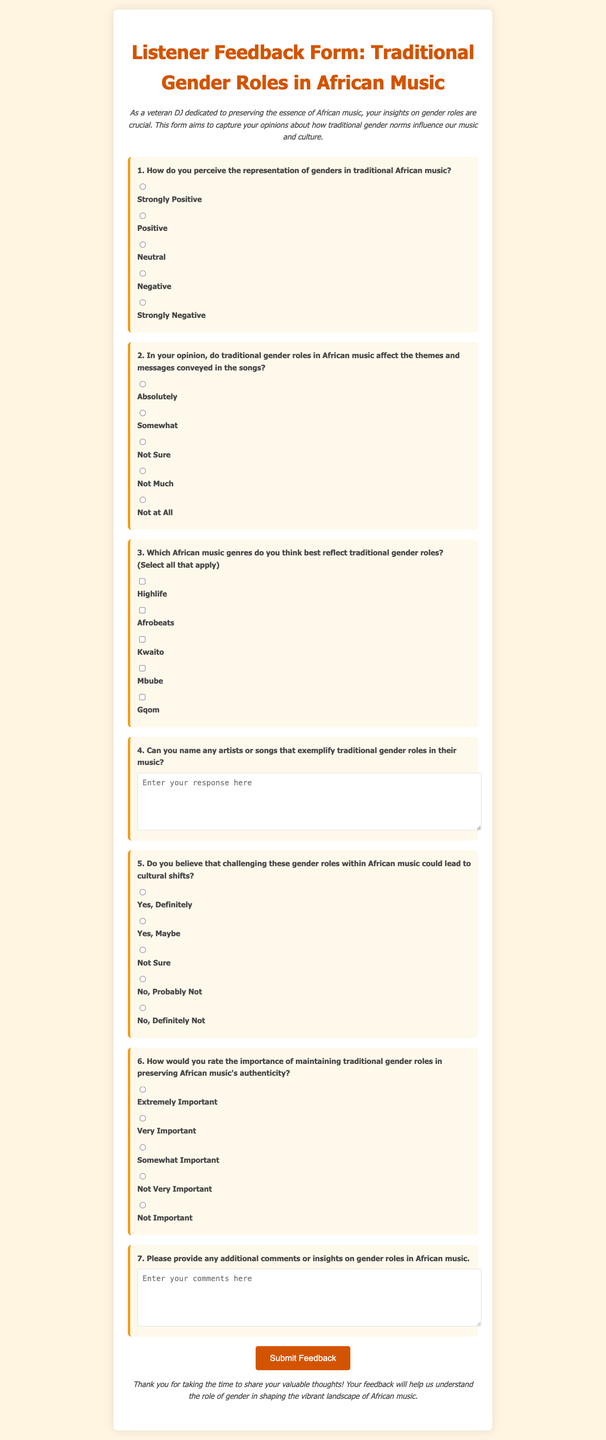What is the title of the document? The title is displayed prominently at the top of the form in a large font.
Answer: Listener Feedback Form: Traditional Gender Roles in African Music What is the purpose of this form? The purpose is described in the introductory paragraph that captures the aim of the survey.
Answer: To capture listener opinions on traditional gender roles in African music How many radio button questions are there in the form? The form contains a total of six distinct radio button questions related to gender roles.
Answer: Six What color is used for the button background? The button's background color is specified in the style section.
Answer: #D35400 What genre can be selected as reflecting traditional gender roles? The checkbox question allows multiple selections from the genres listed.
Answer: Highlife, Afrobeats, Kwaito, Mbube, Gqom What is the designated space for additional comments? The form offers a text area for users to provide more insights or comments.
Answer: Yes, it includes a text area Which question requires participants to name artists or songs? The specific question asking for names is labeled clearly and can be identified easily.
Answer: Question 4 What is the subtitle's focus of the introductory paragraph? The focus of the introductory paragraph emphasizes the importance of listener insights.
Answer: Insights on gender roles 